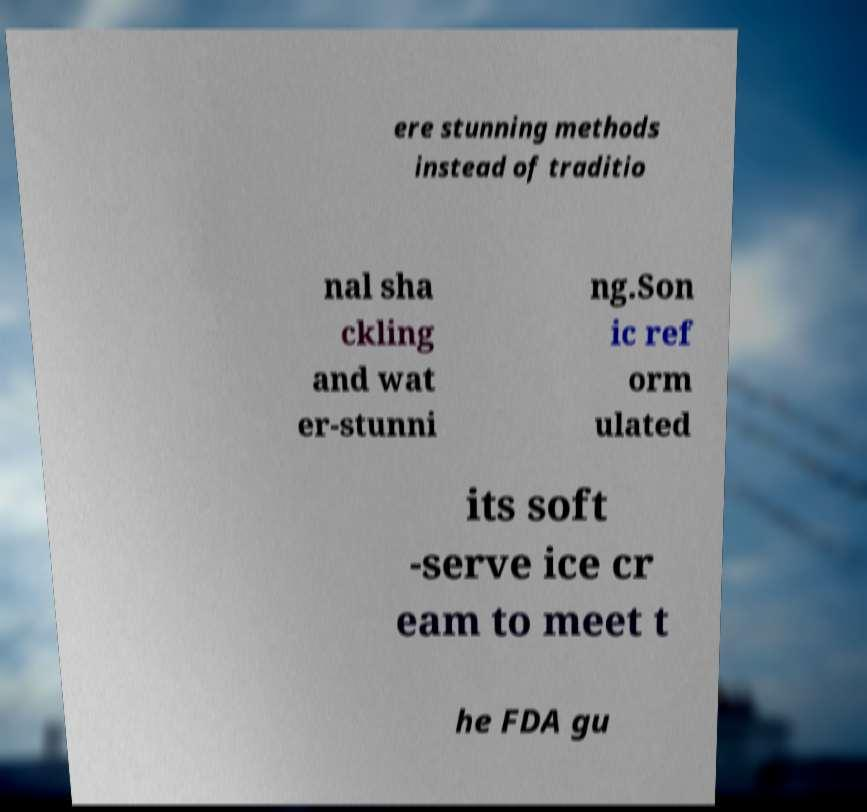There's text embedded in this image that I need extracted. Can you transcribe it verbatim? ere stunning methods instead of traditio nal sha ckling and wat er-stunni ng.Son ic ref orm ulated its soft -serve ice cr eam to meet t he FDA gu 